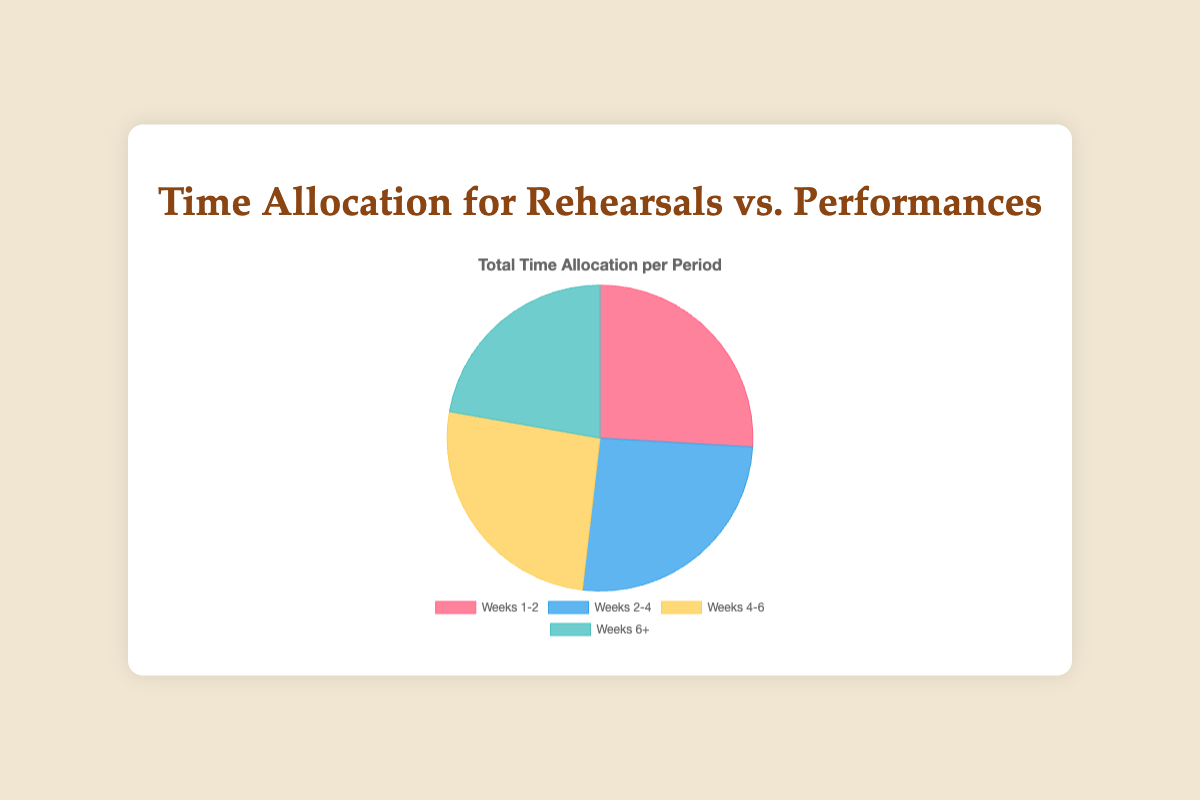what is the sum of time allocated for rehearsals and performances in weeks 6+? To find the sum of time allocated for rehearsals and performances in weeks 6+, add 10 (rehearsals) and 20 (performances). 10 + 20 = 30
Answer: 30 Which period has the smallest total time allocation? By adding both rehearsals and performances for each period: Weeks 1-2 (35), Weeks 2-4 (35), Weeks 4-6 (35), Weeks 6+ (30). The smallest total is in Weeks 6+.
Answer: Weeks 6+ What is the difference in rehearsal time between Weeks 1-2 and Weeks 6+? Subtract the rehearsal time in Weeks 6+ from Weeks 1-2: 30 - 10 = 20
Answer: 20 Which has a greater total time allocation, Weeks 2-4 or Weeks 4-6? Calculate the total time for Weeks 2-4 (25 + 10 = 35) and for Weeks 4-6 (20 + 15 = 35). Both are equal.
Answer: Both are equal What is the average rehearsal time across all periods? Sum all rehearsal times: 30 + 25 + 20 + 10 = 85. Divide by the number of periods: 85 / 4 = 21.25.
Answer: 21.25 Which periods have equal total time allocation? Calculate the total time for each period: Weeks 1-2 (35), Weeks 2-4 (35), Weeks 4-6 (35), Weeks 6+ (30). Weeks 1-2, 2-4, and 4-6 have equal totals.
Answer: Weeks 1-2, Weeks 2-4, Weeks 4-6 What percentage of the total time in Weeks 6+ is spent on performances? The total time in Weeks 6+ is 30. Performances take up 20. Calculate the percentage: (20 / 30) * 100 = 66.67%
Answer: 66.67% How much more time is allocated to performances in Weeks 6+ compared to Weeks 1-2? Subtract the performance time in Weeks 1-2 from Weeks 6+: 20 - 5 = 15
Answer: 15 